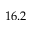Convert formula to latex. <formula><loc_0><loc_0><loc_500><loc_500>1 6 . 2</formula> 